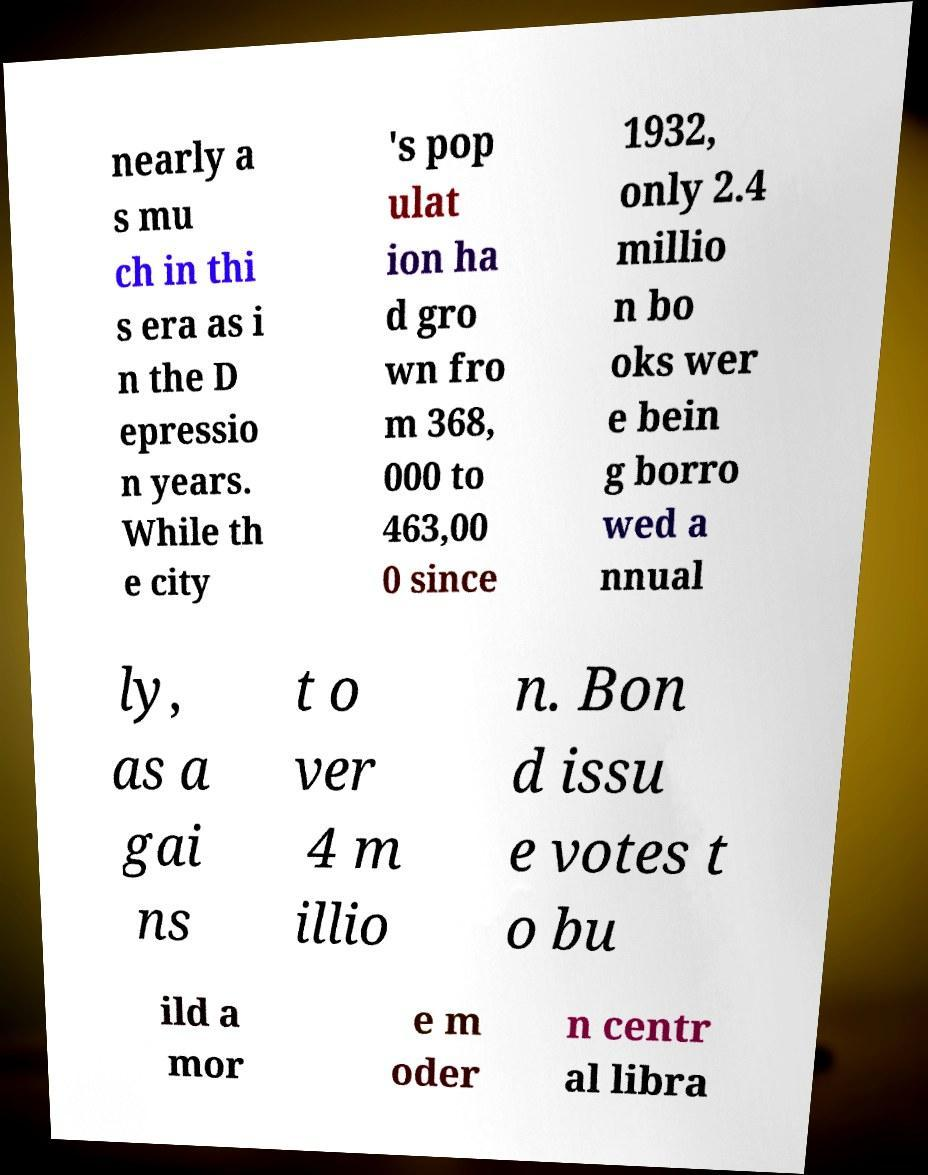Can you accurately transcribe the text from the provided image for me? nearly a s mu ch in thi s era as i n the D epressio n years. While th e city 's pop ulat ion ha d gro wn fro m 368, 000 to 463,00 0 since 1932, only 2.4 millio n bo oks wer e bein g borro wed a nnual ly, as a gai ns t o ver 4 m illio n. Bon d issu e votes t o bu ild a mor e m oder n centr al libra 